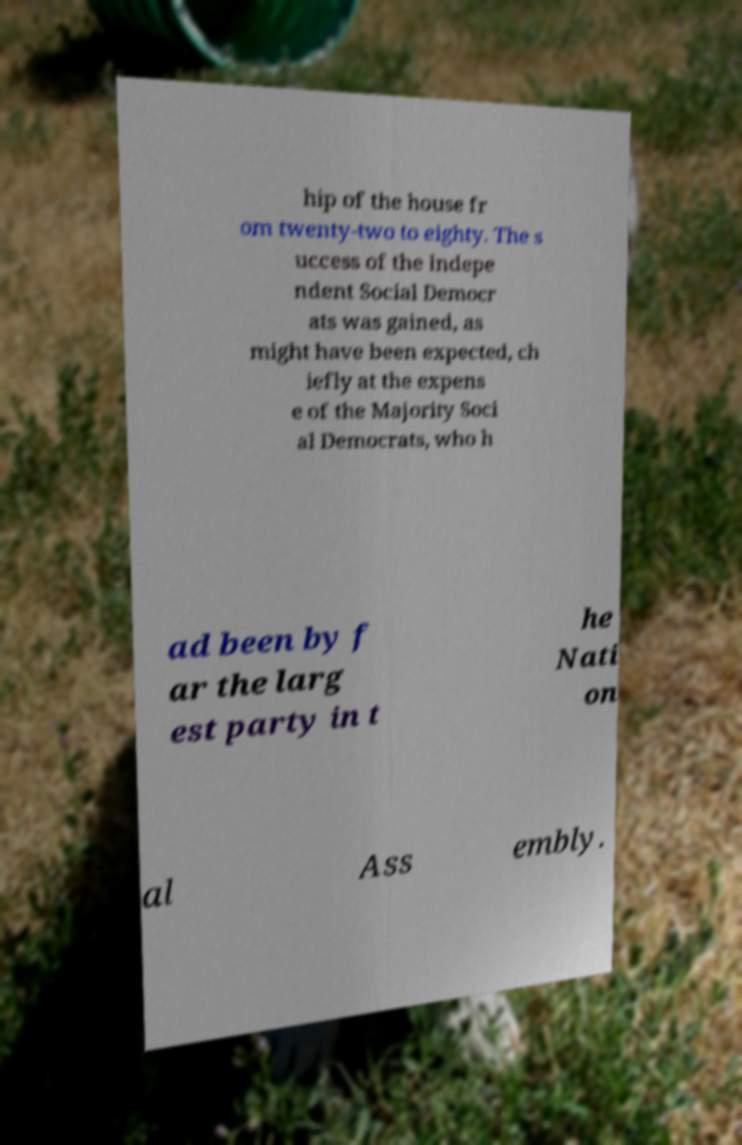For documentation purposes, I need the text within this image transcribed. Could you provide that? hip of the house fr om twenty-two to eighty. The s uccess of the Indepe ndent Social Democr ats was gained, as might have been expected, ch iefly at the expens e of the Majority Soci al Democrats, who h ad been by f ar the larg est party in t he Nati on al Ass embly. 